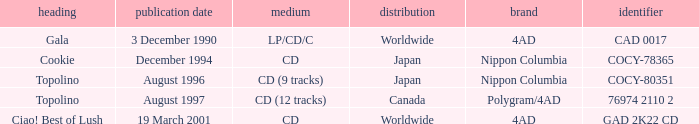Help me parse the entirety of this table. {'header': ['heading', 'publication date', 'medium', 'distribution', 'brand', 'identifier'], 'rows': [['Gala', '3 December 1990', 'LP/CD/C', 'Worldwide', '4AD', 'CAD 0017'], ['Cookie', 'December 1994', 'CD', 'Japan', 'Nippon Columbia', 'COCY-78365'], ['Topolino', 'August 1996', 'CD (9 tracks)', 'Japan', 'Nippon Columbia', 'COCY-80351'], ['Topolino', 'August 1997', 'CD (12 tracks)', 'Canada', 'Polygram/4AD', '76974 2110 2'], ['Ciao! Best of Lush', '19 March 2001', 'CD', 'Worldwide', '4AD', 'GAD 2K22 CD']]} What Label released an album in August 1996? Nippon Columbia. 